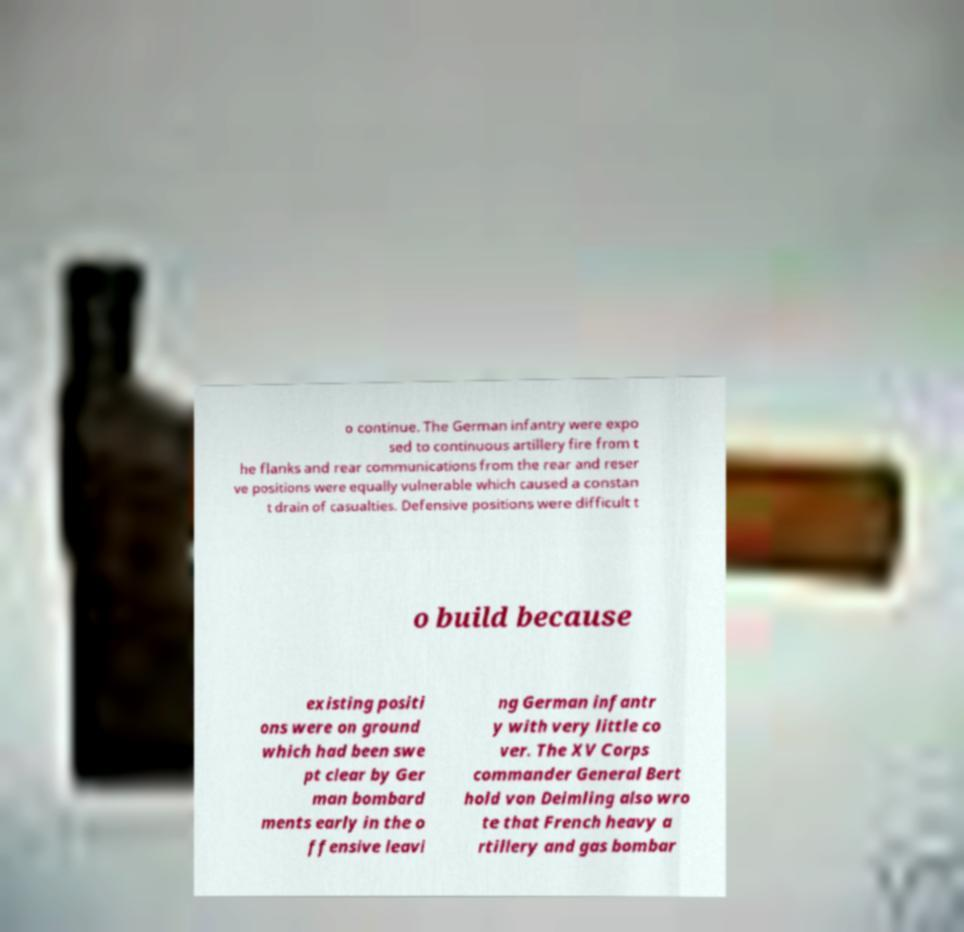I need the written content from this picture converted into text. Can you do that? o continue. The German infantry were expo sed to continuous artillery fire from t he flanks and rear communications from the rear and reser ve positions were equally vulnerable which caused a constan t drain of casualties. Defensive positions were difficult t o build because existing positi ons were on ground which had been swe pt clear by Ger man bombard ments early in the o ffensive leavi ng German infantr y with very little co ver. The XV Corps commander General Bert hold von Deimling also wro te that French heavy a rtillery and gas bombar 